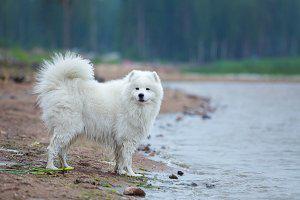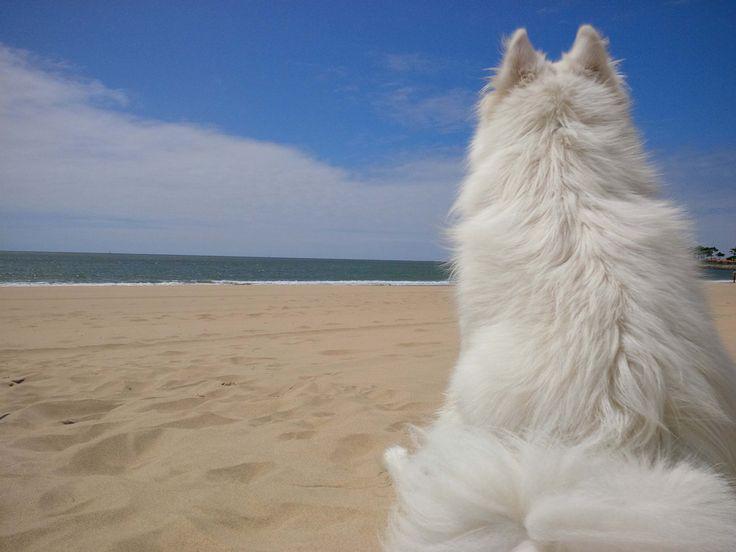The first image is the image on the left, the second image is the image on the right. For the images displayed, is the sentence "The left image contains a white dog swimming in water." factually correct? Answer yes or no. No. The first image is the image on the left, the second image is the image on the right. Analyze the images presented: Is the assertion "In at least one image, a white dog is seen swimming in water" valid? Answer yes or no. No. 